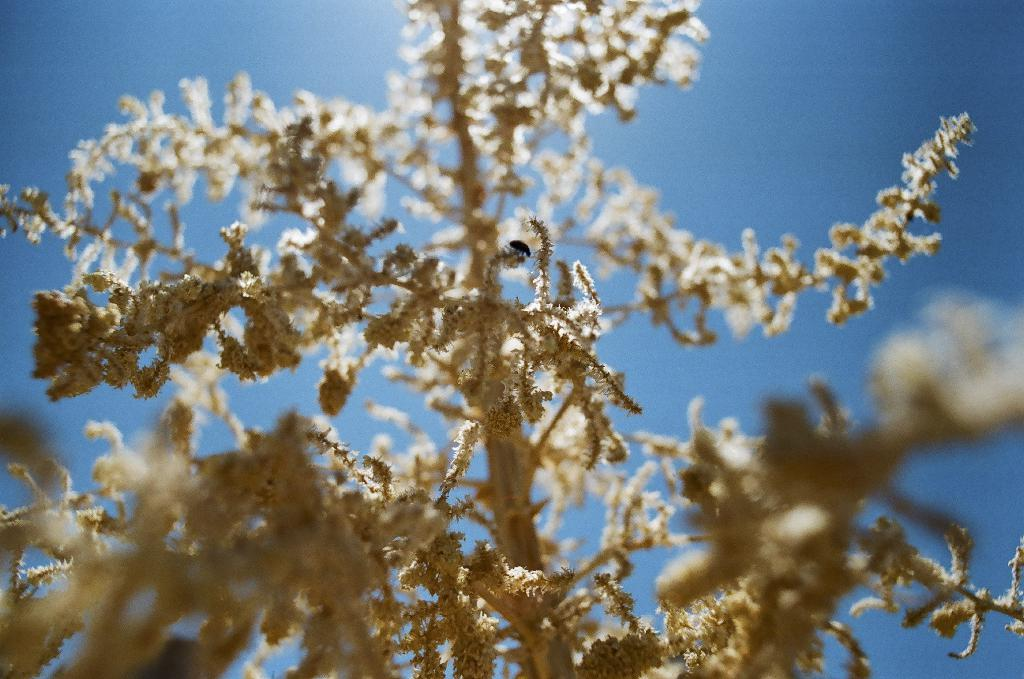What type of living organism can be seen in the image? There is a plant in the image. What can be seen in the background of the image? The sky is visible in the background of the image. How many books are stacked on the plant in the image? There are no books present in the image; it only features a plant and the sky in the background. 